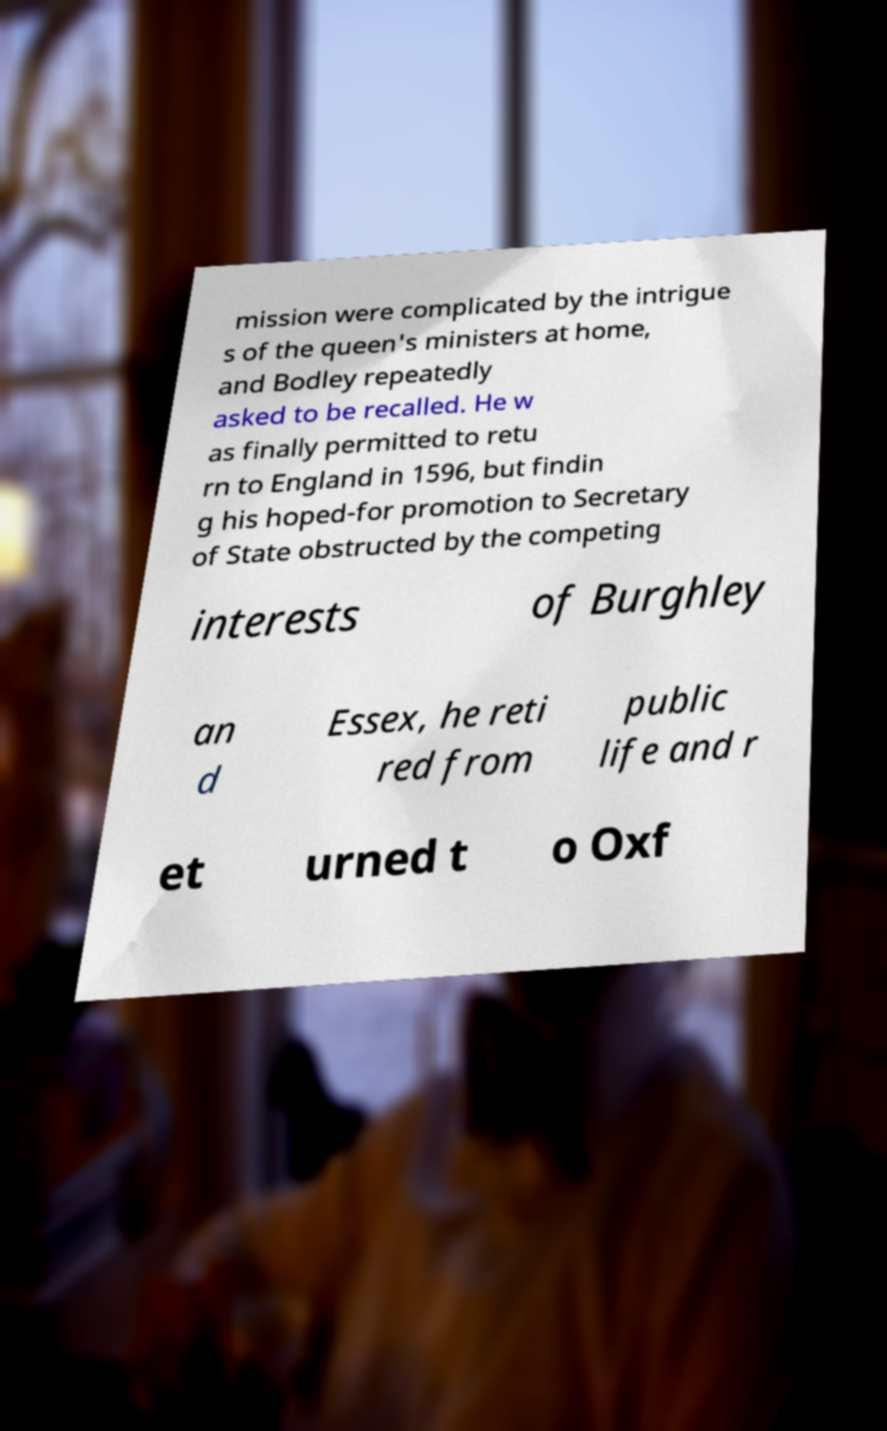Can you accurately transcribe the text from the provided image for me? mission were complicated by the intrigue s of the queen's ministers at home, and Bodley repeatedly asked to be recalled. He w as finally permitted to retu rn to England in 1596, but findin g his hoped-for promotion to Secretary of State obstructed by the competing interests of Burghley an d Essex, he reti red from public life and r et urned t o Oxf 